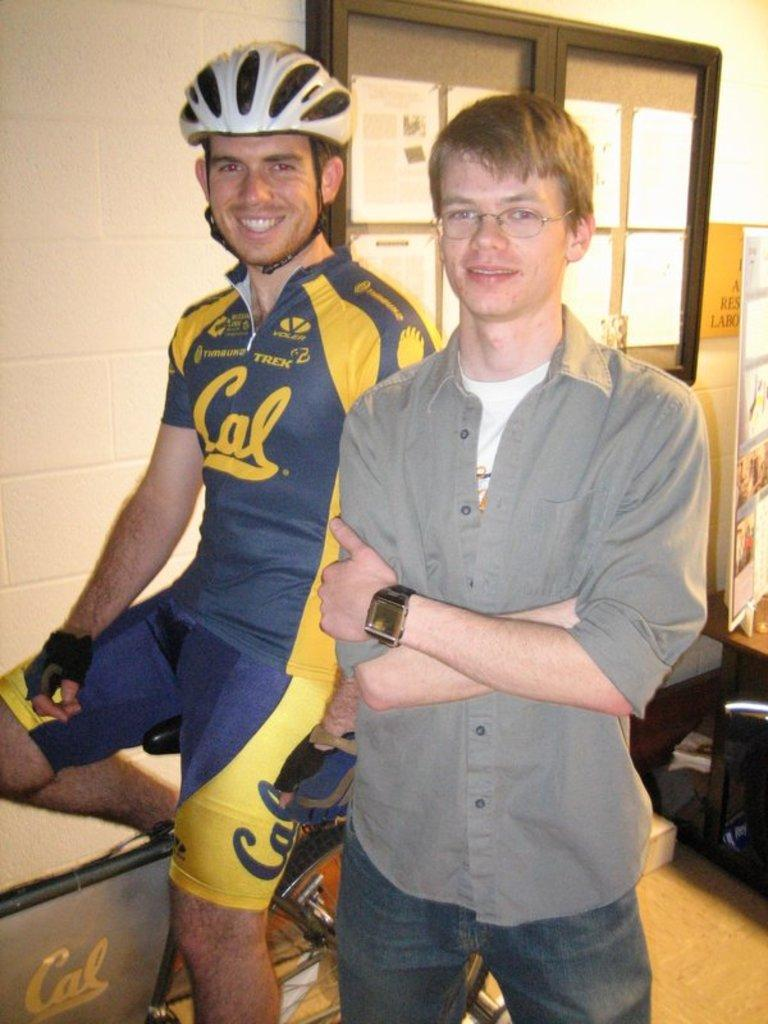How many people are in the image? There are two men in the image. What expressions do the men have? Both men are smiling in the image. What is one man doing in the image? One man is sitting on a bicycle. What can be seen in the background of the image? There is a notice board and a wall in the background. How many children are playing on the island in the image? There is no island or children present in the image. What color is the tongue of the man on the bicycle? There is no mention of a tongue in the image, and it is not visible in the provided facts. 